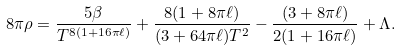Convert formula to latex. <formula><loc_0><loc_0><loc_500><loc_500>8 \pi \rho = \frac { 5 \beta } { T ^ { 8 ( 1 + 1 6 \pi \ell ) } } + \frac { 8 ( 1 + 8 \pi \ell ) } { ( 3 + 6 4 \pi \ell ) T ^ { 2 } } - \frac { ( 3 + 8 \pi \ell ) } { 2 ( 1 + 1 6 \pi \ell ) } + \Lambda .</formula> 